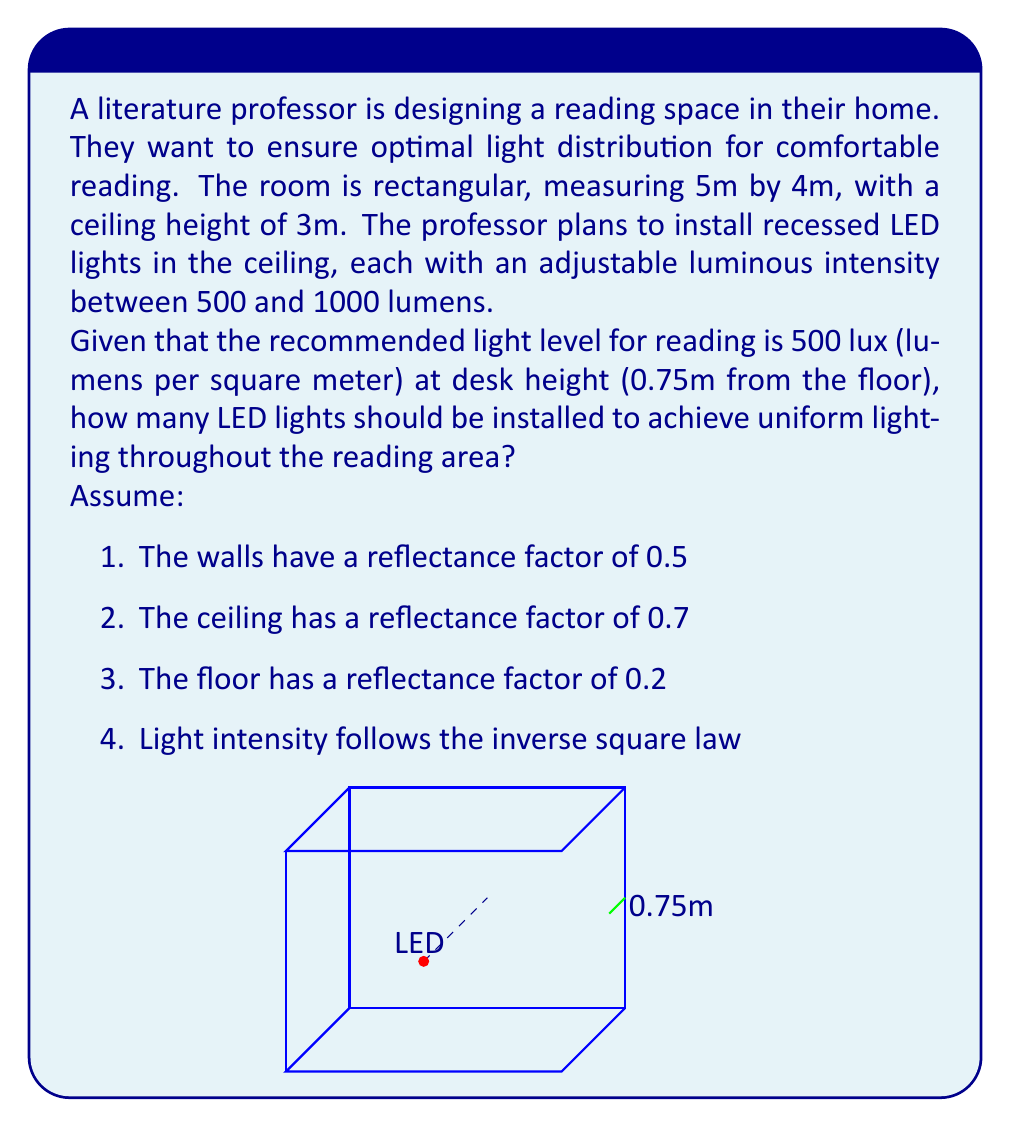Give your solution to this math problem. Let's approach this step-by-step:

1) First, we need to calculate the total area of the room:
   $A = 5m \times 4m = 20m^2$

2) The total lumens needed at desk height:
   $Total\;lumens = 500\;lux \times 20m^2 = 10,000\;lumens$

3) To account for light absorption by surfaces, we use the Room Cavity Ratio (RCR):
   $RCR = \frac{5 \times room\;height \times (length + width)}{length \times width}$
   $RCR = \frac{5 \times 3 \times (5 + 4)}{5 \times 4} = 6.75$

4) Using the RCR and surface reflectances, we can estimate the Light Loss Factor (LLF):
   $LLF \approx 0.7$ (typical value for these conditions)

5) Accounting for LLF, the actual lumens needed:
   $Actual\;lumens = \frac{10,000}{0.7} \approx 14,286\;lumens$

6) Now, we need to consider the inverse square law. At desk height (2.25m from the ceiling):
   $Intensity_{desk} = Intensity_{source} \times (\frac{1}{2.25})^2 \approx 0.2 \times Intensity_{source}$

7) So, the total lumens at the source should be:
   $Source\;lumens = \frac{14,286}{0.2} \approx 71,430\;lumens$

8) If each LED can provide up to 1000 lumens:
   $Number\;of\;LEDs = \frac{71,430}{1000} \approx 71.43$

9) Rounding up to ensure sufficient lighting:
   $Number\;of\;LEDs = 72$
Answer: 72 LED lights 